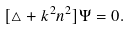<formula> <loc_0><loc_0><loc_500><loc_500>[ \triangle + k ^ { 2 } n ^ { 2 } ] \Psi = 0 .</formula> 